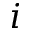<formula> <loc_0><loc_0><loc_500><loc_500>i</formula> 